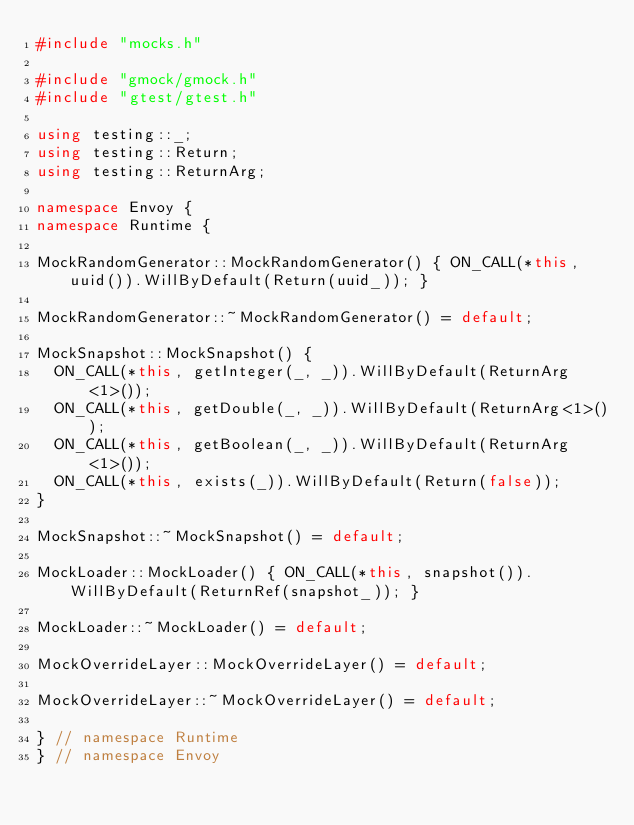Convert code to text. <code><loc_0><loc_0><loc_500><loc_500><_C++_>#include "mocks.h"

#include "gmock/gmock.h"
#include "gtest/gtest.h"

using testing::_;
using testing::Return;
using testing::ReturnArg;

namespace Envoy {
namespace Runtime {

MockRandomGenerator::MockRandomGenerator() { ON_CALL(*this, uuid()).WillByDefault(Return(uuid_)); }

MockRandomGenerator::~MockRandomGenerator() = default;

MockSnapshot::MockSnapshot() {
  ON_CALL(*this, getInteger(_, _)).WillByDefault(ReturnArg<1>());
  ON_CALL(*this, getDouble(_, _)).WillByDefault(ReturnArg<1>());
  ON_CALL(*this, getBoolean(_, _)).WillByDefault(ReturnArg<1>());
  ON_CALL(*this, exists(_)).WillByDefault(Return(false));
}

MockSnapshot::~MockSnapshot() = default;

MockLoader::MockLoader() { ON_CALL(*this, snapshot()).WillByDefault(ReturnRef(snapshot_)); }

MockLoader::~MockLoader() = default;

MockOverrideLayer::MockOverrideLayer() = default;

MockOverrideLayer::~MockOverrideLayer() = default;

} // namespace Runtime
} // namespace Envoy
</code> 